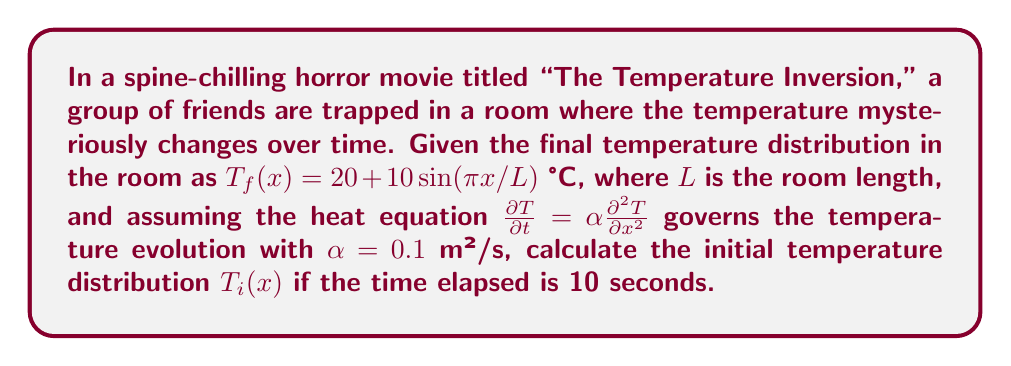Solve this math problem. To solve this inverse problem, we'll use the following steps:

1) The general solution to the heat equation in one dimension is:

   $$T(x,t) = \sum_{n=1}^{\infty} A_n \sin(\frac{n\pi x}{L}) e^{-\alpha (\frac{n\pi}{L})^2 t}$$

2) Given the final temperature distribution:

   $$T_f(x) = 20 + 10\sin(\frac{\pi x}{L})$$

   We can see that $n=1$ and $A_1 = 10$. The constant term 20 doesn't change with time.

3) To find the initial distribution, we need to "reverse" the exponential decay:

   $$T_i(x) = 20 + 10\sin(\frac{\pi x}{L}) / e^{-\alpha (\frac{\pi}{L})^2 t}$$

4) Substituting the given values ($\alpha = 0.1$ m²/s, $t = 10$ s):

   $$T_i(x) = 20 + 10\sin(\frac{\pi x}{L}) / e^{-0.1 (\frac{\pi}{L})^2 10}$$

5) Simplify the exponent:

   $$T_i(x) = 20 + 10\sin(\frac{\pi x}{L}) / e^{-\frac{\pi^2}{L^2}}$$

6) The final initial temperature distribution is:

   $$T_i(x) = 20 + 10e^{\frac{\pi^2}{L^2}}\sin(\frac{\pi x}{L})$$
Answer: $T_i(x) = 20 + 10e^{\frac{\pi^2}{L^2}}\sin(\frac{\pi x}{L})$ °C 